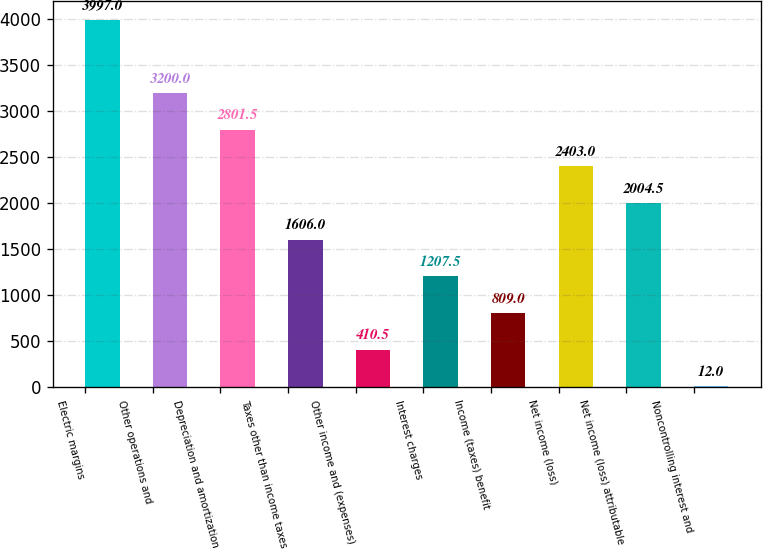<chart> <loc_0><loc_0><loc_500><loc_500><bar_chart><fcel>Electric margins<fcel>Other operations and<fcel>Depreciation and amortization<fcel>Taxes other than income taxes<fcel>Other income and (expenses)<fcel>Interest charges<fcel>Income (taxes) benefit<fcel>Net income (loss)<fcel>Net income (loss) attributable<fcel>Noncontrolling interest and<nl><fcel>3997<fcel>3200<fcel>2801.5<fcel>1606<fcel>410.5<fcel>1207.5<fcel>809<fcel>2403<fcel>2004.5<fcel>12<nl></chart> 